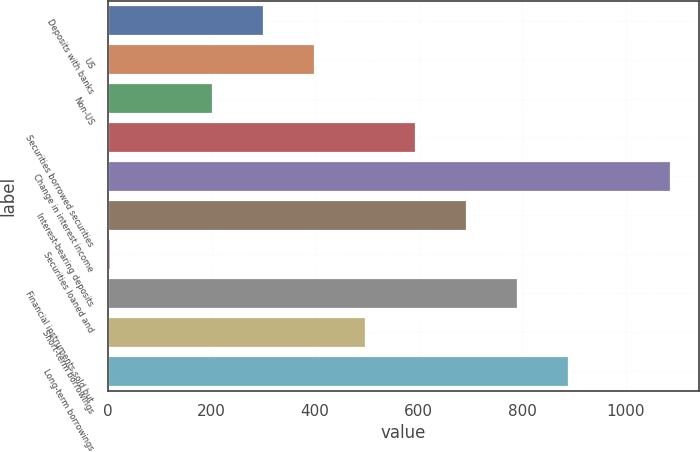Convert chart to OTSL. <chart><loc_0><loc_0><loc_500><loc_500><bar_chart><fcel>Deposits with banks<fcel>US<fcel>Non-US<fcel>Securities borrowed securities<fcel>Change in interest income<fcel>Interest-bearing deposits<fcel>Securities loaned and<fcel>Financial instruments sold but<fcel>Short-term borrowings<fcel>Long-term borrowings<nl><fcel>300.9<fcel>399.2<fcel>202.6<fcel>595.8<fcel>1087.3<fcel>694.1<fcel>6<fcel>792.4<fcel>497.5<fcel>890.7<nl></chart> 